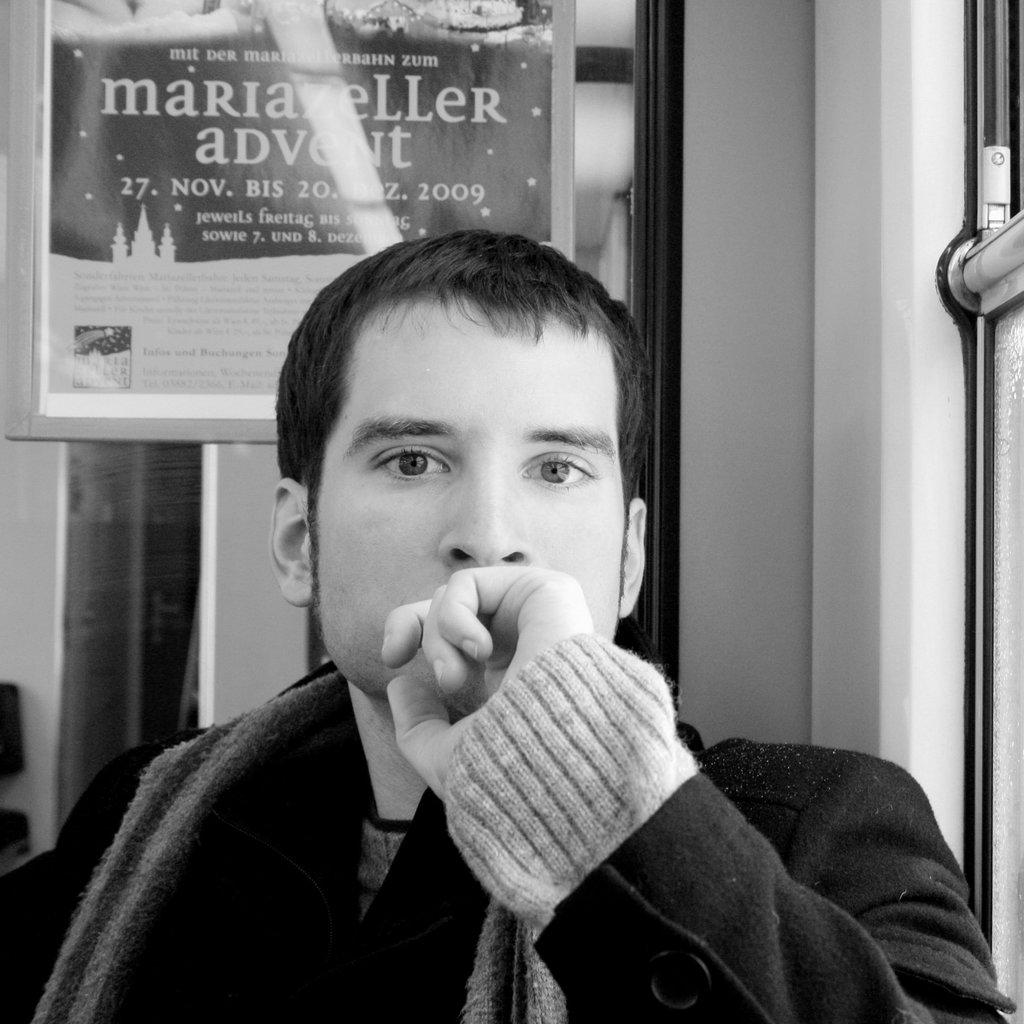What is the color scheme of the image? The image is black and white. Who or what is the main subject in the image? There is a person in the center of the image. What can be seen in the background of the image? There is a frame in the background of the image. What is written or depicted in the frame? Text is present in the frame. Can you see a kitty playing with a hook in the image? No, there is no kitty or hook present in the image. What type of motion is the person in the image exhibiting? The image is black and white and does not show any motion; it is a still image. 